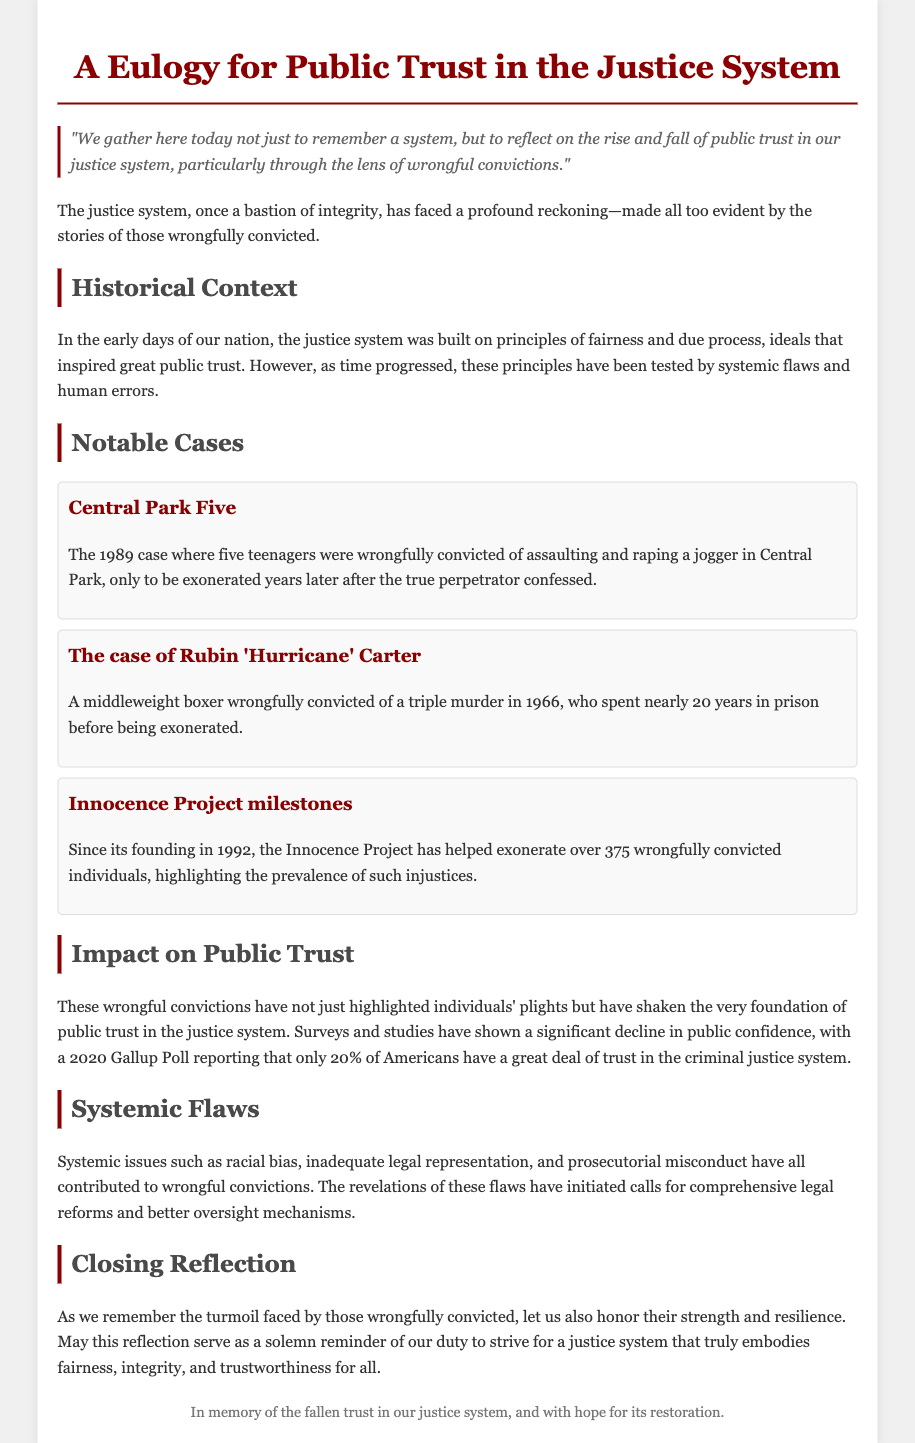What year did the Central Park Five case occur? The document states that the Central Park Five case occurred in 1989.
Answer: 1989 How many individuals has the Innocence Project exonerated? According to the document, the Innocence Project has helped exonerate over 375 wrongfully convicted individuals.
Answer: Over 375 What was the public trust percentage in the justice system according to the 2020 Gallup Poll? The document mentions that only 20% of Americans have a great deal of trust in the criminal justice system in the 2020 Gallup Poll.
Answer: 20% What systemic issue contributes to wrongful convictions? The document lists racial bias, inadequate legal representation, and prosecutorial misconduct as systemic issues contributing to wrongful convictions.
Answer: Racial bias What does the quote in the document emphasize? The quote emphasizes the need to reflect on the rise and fall of public trust in the justice system due to wrongful convictions.
Answer: Reflection on public trust What notable case involved Rubin 'Hurricane' Carter? The document specifies that Rubin 'Hurricane' Carter was wrongfully convicted of a triple murder in 1966.
Answer: Triple murder What does the eulogy serve as a reminder of? The closing reflection in the document mentions that the eulogy serves as a solemn reminder of the duty to strive for a fair justice system.
Answer: Duty to strive for a fair justice system What is the document's primary focus? The primary focus of the document is on the rise and fall of public trust in the justice system due to wrongful convictions.
Answer: Public trust in the justice system 